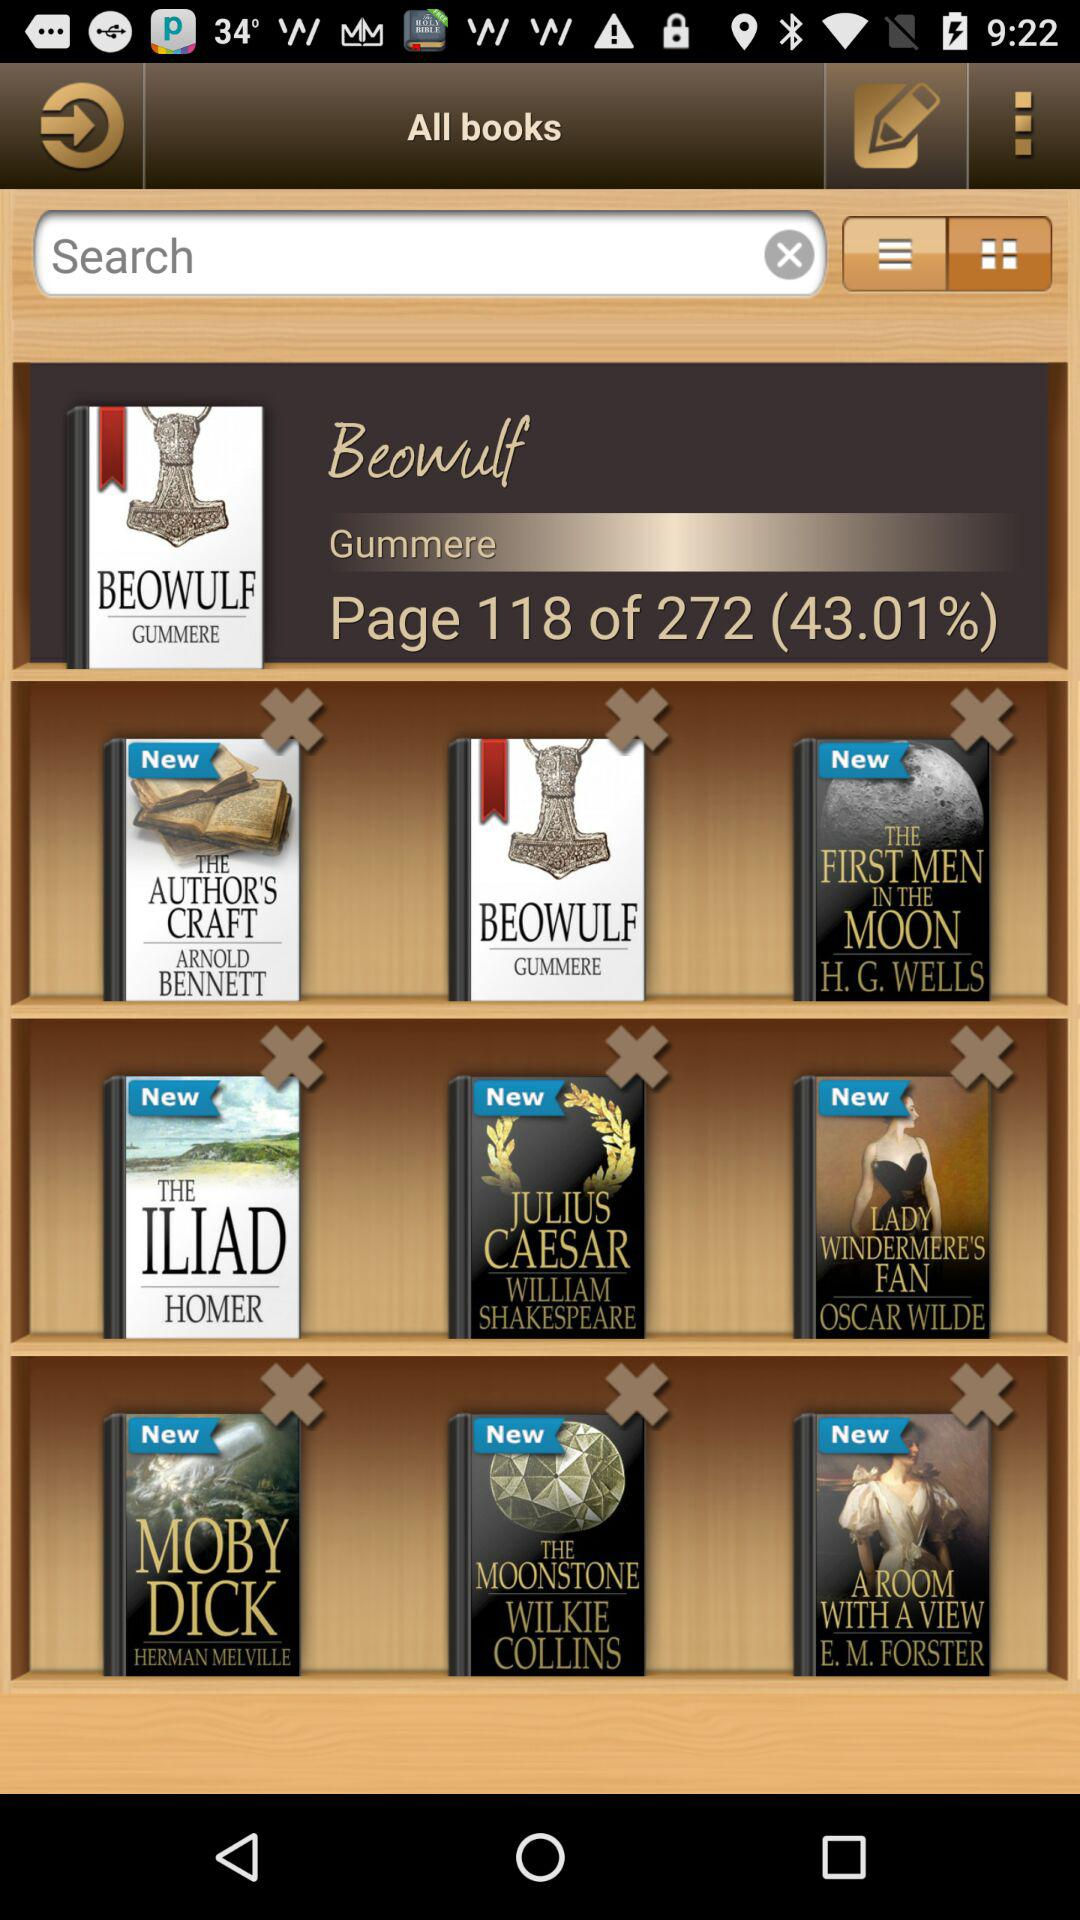How many pages of the book "Beowulf" have been downloaded? There are 118 pages of the book "Beowulf" that have been downloaded. 